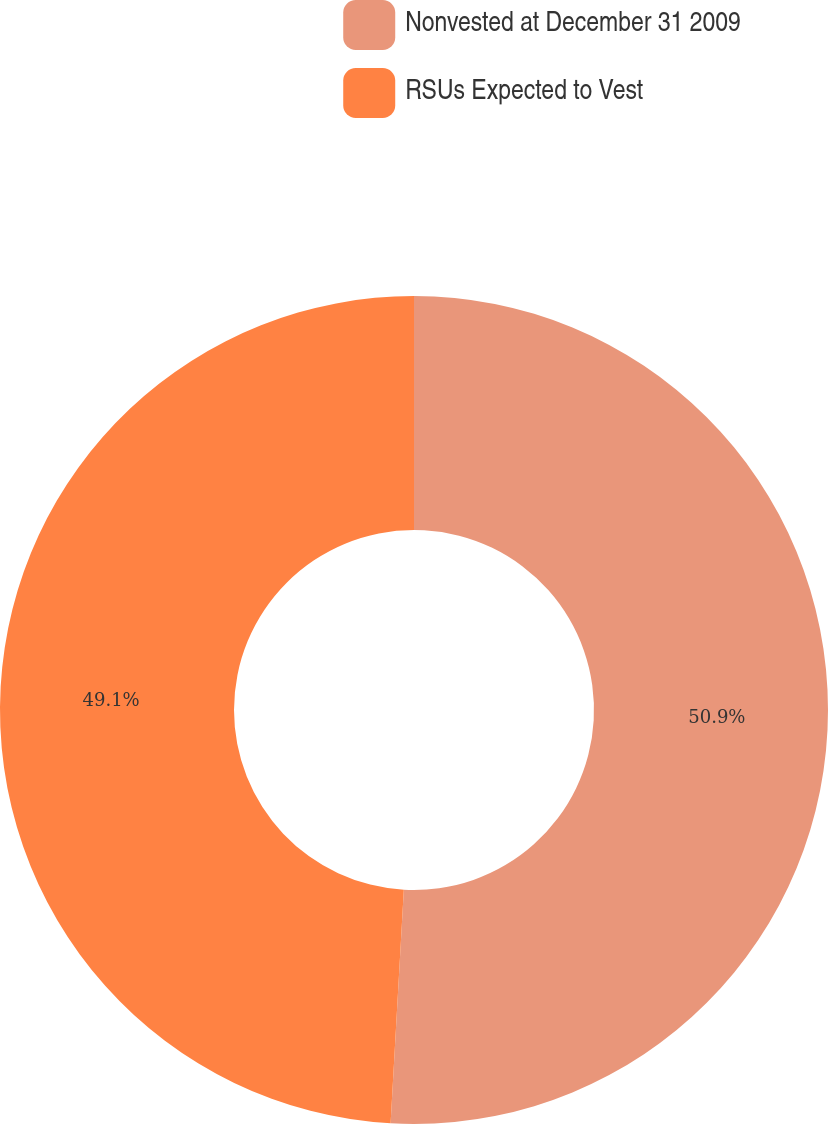Convert chart. <chart><loc_0><loc_0><loc_500><loc_500><pie_chart><fcel>Nonvested at December 31 2009<fcel>RSUs Expected to Vest<nl><fcel>50.9%<fcel>49.1%<nl></chart> 